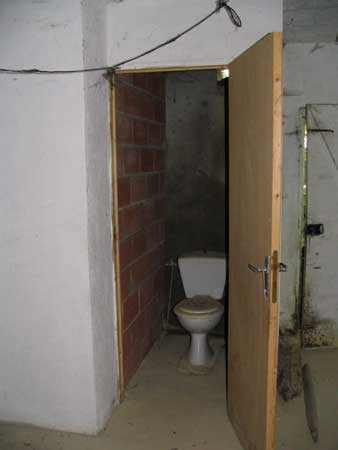Describe the objects in this image and their specific colors. I can see a toilet in gray and black tones in this image. 